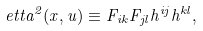Convert formula to latex. <formula><loc_0><loc_0><loc_500><loc_500>\ e t t a ^ { 2 } ( x , u ) \equiv F _ { i k } F _ { j l } h ^ { i j } h ^ { k l } ,</formula> 